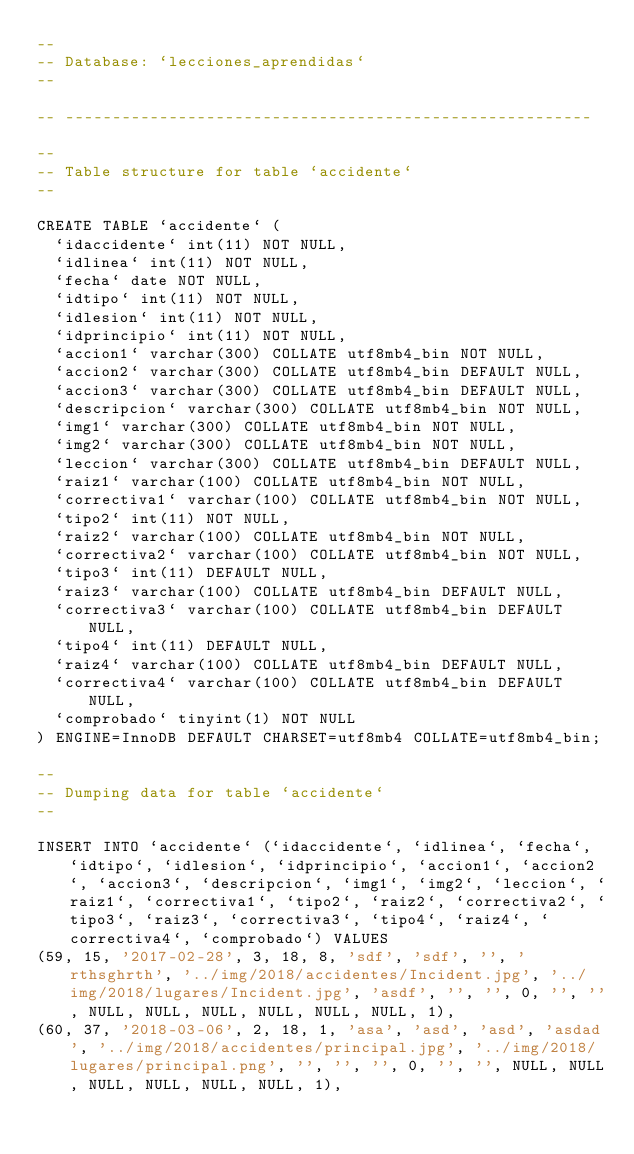<code> <loc_0><loc_0><loc_500><loc_500><_SQL_>--
-- Database: `lecciones_aprendidas`
--

-- --------------------------------------------------------

--
-- Table structure for table `accidente`
--

CREATE TABLE `accidente` (
  `idaccidente` int(11) NOT NULL,
  `idlinea` int(11) NOT NULL,
  `fecha` date NOT NULL,
  `idtipo` int(11) NOT NULL,
  `idlesion` int(11) NOT NULL,
  `idprincipio` int(11) NOT NULL,
  `accion1` varchar(300) COLLATE utf8mb4_bin NOT NULL,
  `accion2` varchar(300) COLLATE utf8mb4_bin DEFAULT NULL,
  `accion3` varchar(300) COLLATE utf8mb4_bin DEFAULT NULL,
  `descripcion` varchar(300) COLLATE utf8mb4_bin NOT NULL,
  `img1` varchar(300) COLLATE utf8mb4_bin NOT NULL,
  `img2` varchar(300) COLLATE utf8mb4_bin NOT NULL,
  `leccion` varchar(300) COLLATE utf8mb4_bin DEFAULT NULL,
  `raiz1` varchar(100) COLLATE utf8mb4_bin NOT NULL,
  `correctiva1` varchar(100) COLLATE utf8mb4_bin NOT NULL,
  `tipo2` int(11) NOT NULL,
  `raiz2` varchar(100) COLLATE utf8mb4_bin NOT NULL,
  `correctiva2` varchar(100) COLLATE utf8mb4_bin NOT NULL,
  `tipo3` int(11) DEFAULT NULL,
  `raiz3` varchar(100) COLLATE utf8mb4_bin DEFAULT NULL,
  `correctiva3` varchar(100) COLLATE utf8mb4_bin DEFAULT NULL,
  `tipo4` int(11) DEFAULT NULL,
  `raiz4` varchar(100) COLLATE utf8mb4_bin DEFAULT NULL,
  `correctiva4` varchar(100) COLLATE utf8mb4_bin DEFAULT NULL,
  `comprobado` tinyint(1) NOT NULL
) ENGINE=InnoDB DEFAULT CHARSET=utf8mb4 COLLATE=utf8mb4_bin;

--
-- Dumping data for table `accidente`
--

INSERT INTO `accidente` (`idaccidente`, `idlinea`, `fecha`, `idtipo`, `idlesion`, `idprincipio`, `accion1`, `accion2`, `accion3`, `descripcion`, `img1`, `img2`, `leccion`, `raiz1`, `correctiva1`, `tipo2`, `raiz2`, `correctiva2`, `tipo3`, `raiz3`, `correctiva3`, `tipo4`, `raiz4`, `correctiva4`, `comprobado`) VALUES
(59, 15, '2017-02-28', 3, 18, 8, 'sdf', 'sdf', '', 'rthsghrth', '../img/2018/accidentes/Incident.jpg', '../img/2018/lugares/Incident.jpg', 'asdf', '', '', 0, '', '', NULL, NULL, NULL, NULL, NULL, NULL, 1),
(60, 37, '2018-03-06', 2, 18, 1, 'asa', 'asd', 'asd', 'asdad', '../img/2018/accidentes/principal.jpg', '../img/2018/lugares/principal.png', '', '', '', 0, '', '', NULL, NULL, NULL, NULL, NULL, NULL, 1),</code> 